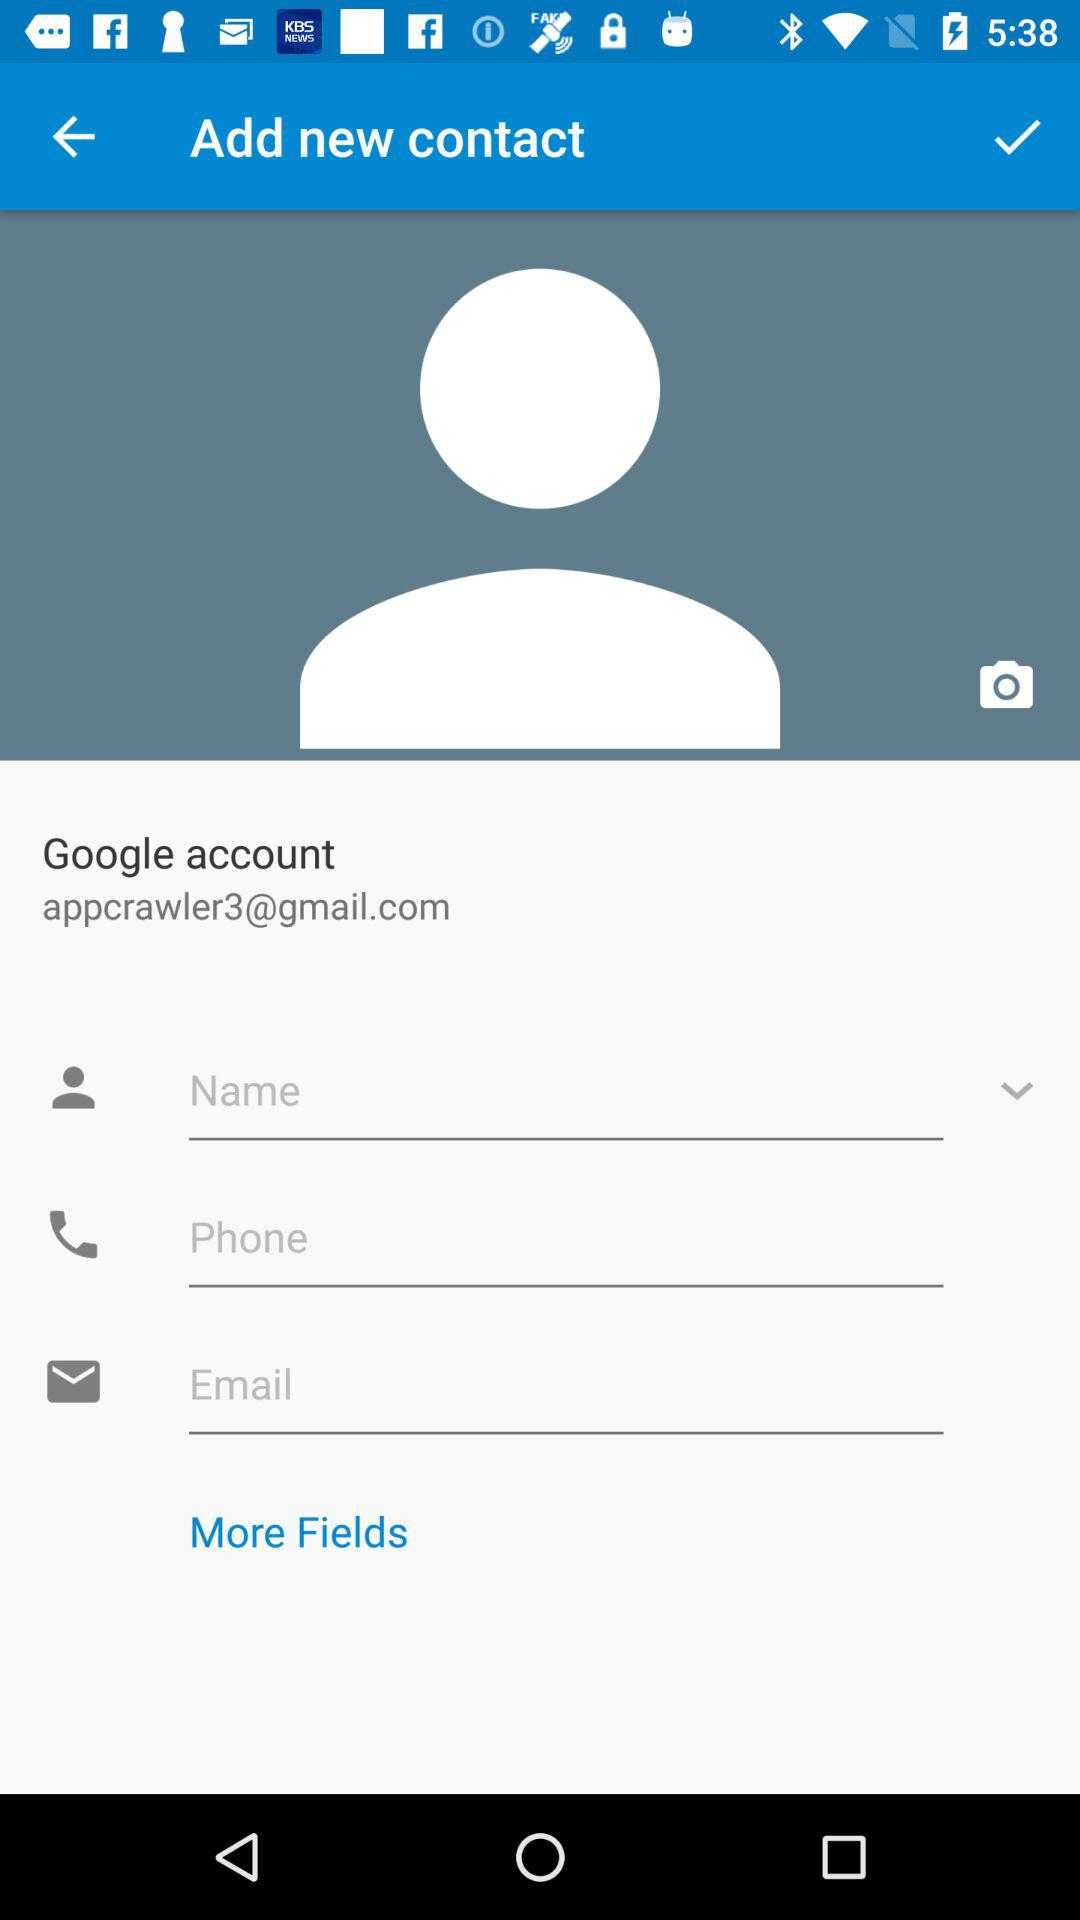How many text inputs are there after the name field?
Answer the question using a single word or phrase. 2 